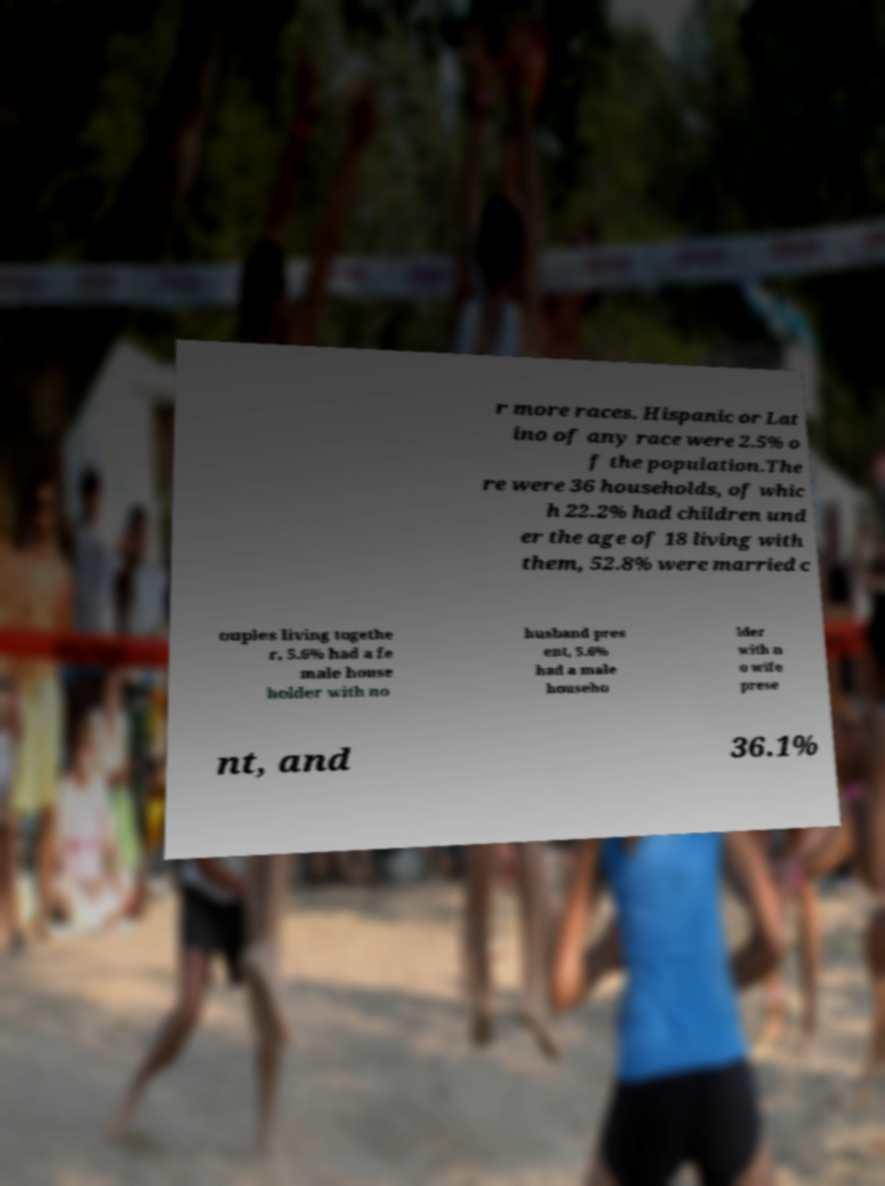Could you extract and type out the text from this image? r more races. Hispanic or Lat ino of any race were 2.5% o f the population.The re were 36 households, of whic h 22.2% had children und er the age of 18 living with them, 52.8% were married c ouples living togethe r, 5.6% had a fe male house holder with no husband pres ent, 5.6% had a male househo lder with n o wife prese nt, and 36.1% 